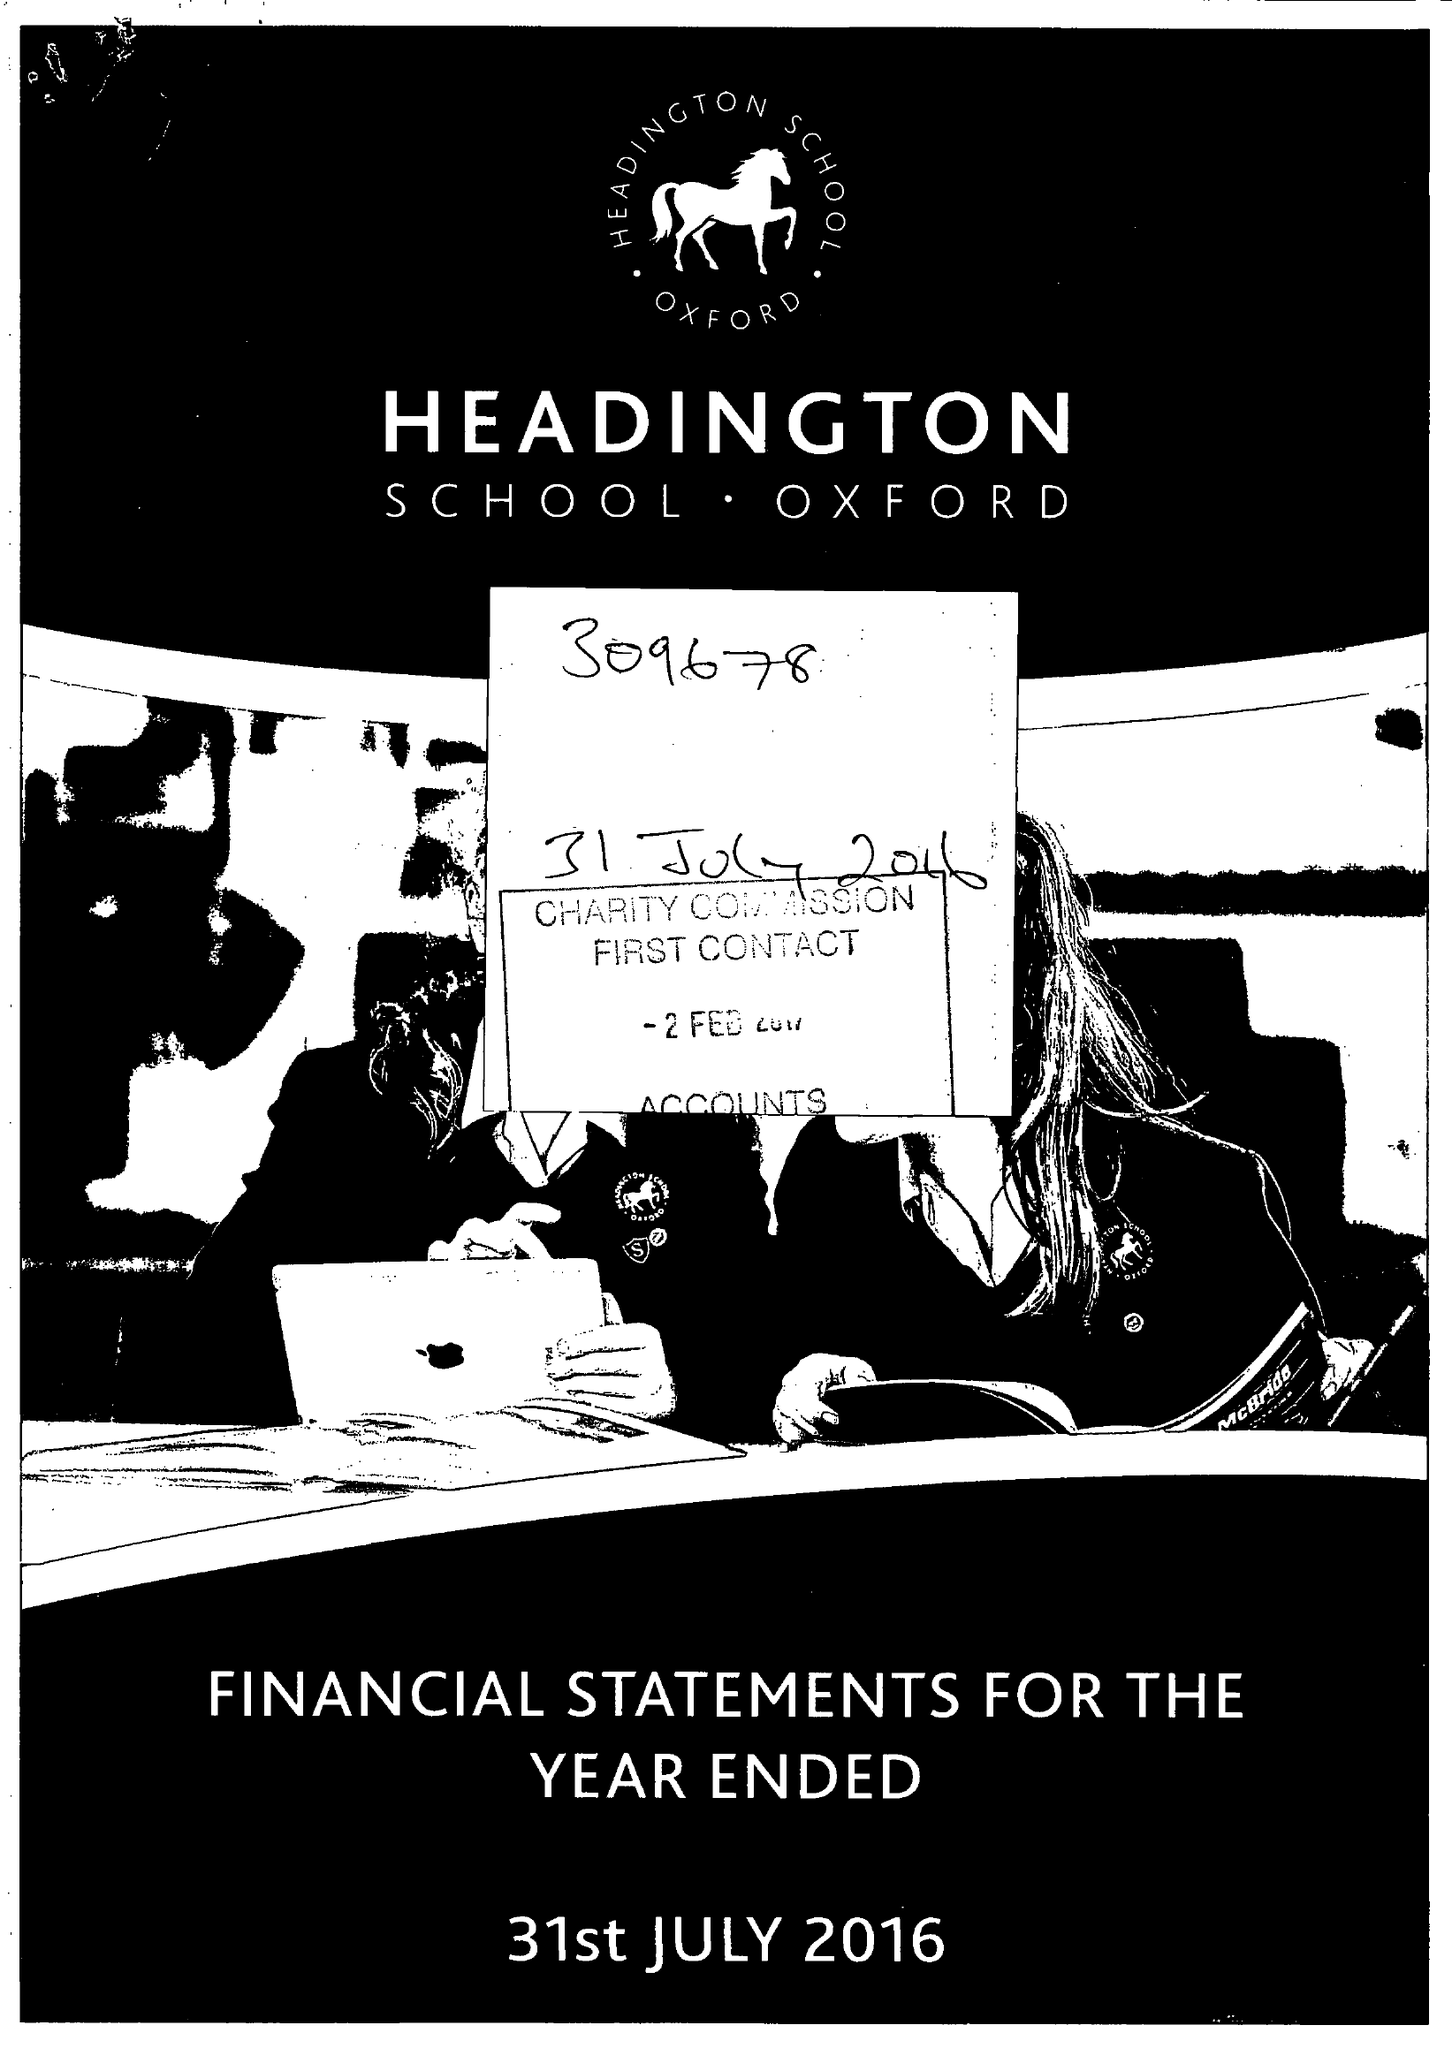What is the value for the spending_annually_in_british_pounds?
Answer the question using a single word or phrase. 18367345.00 